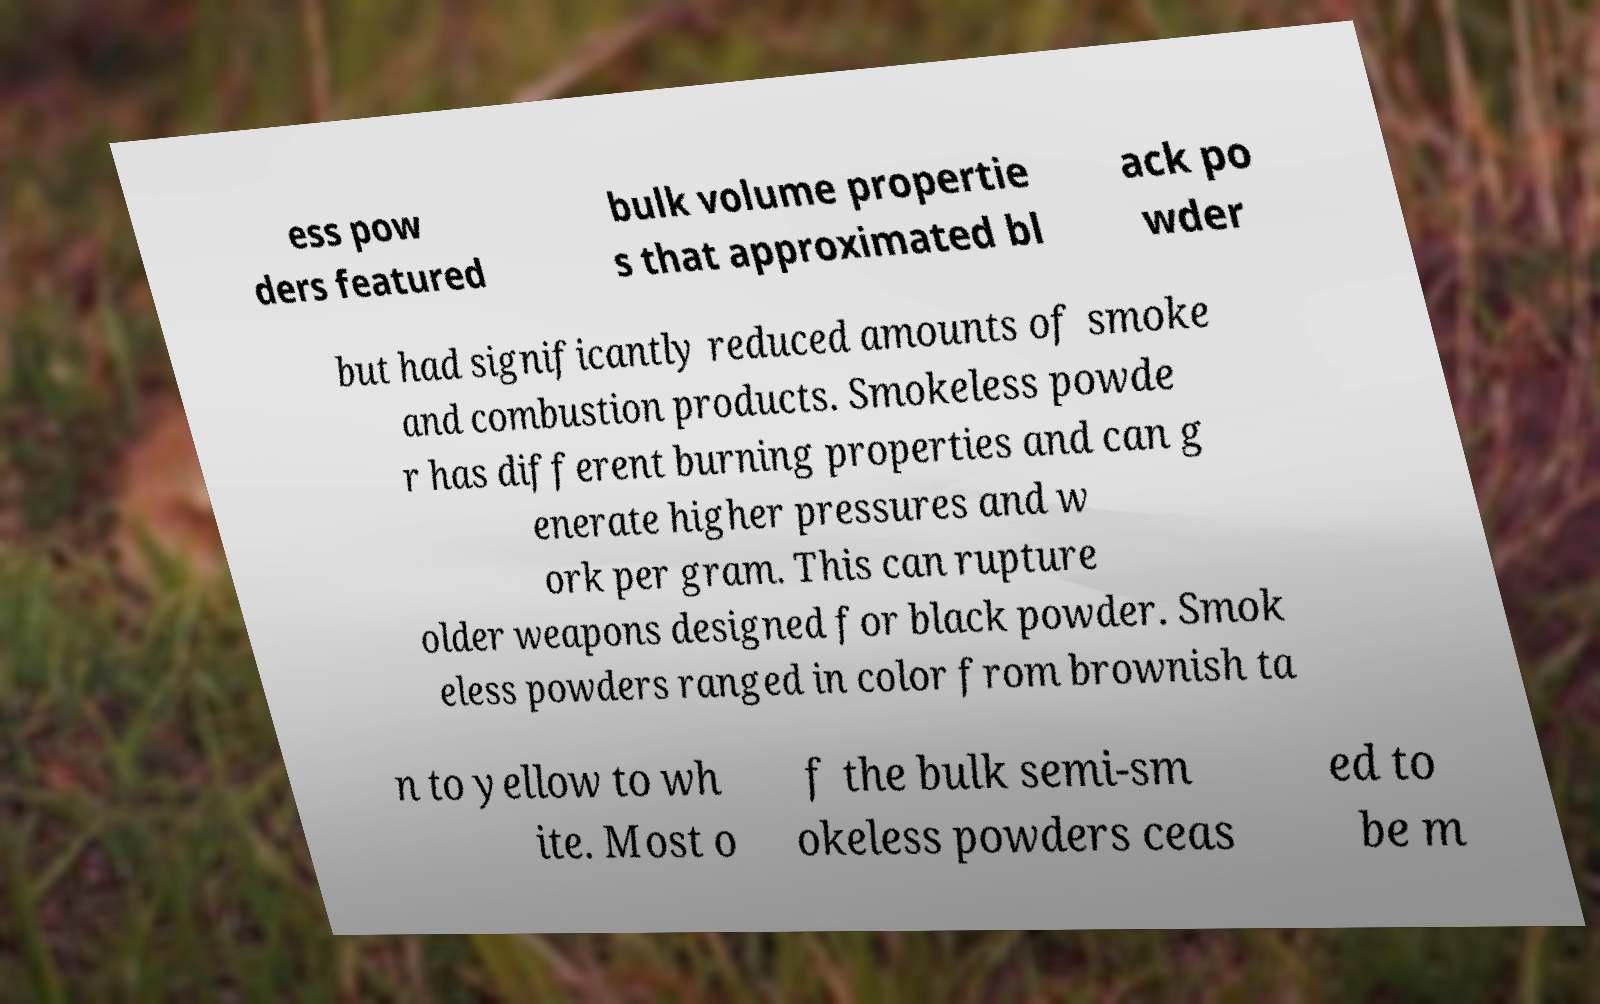There's text embedded in this image that I need extracted. Can you transcribe it verbatim? ess pow ders featured bulk volume propertie s that approximated bl ack po wder but had significantly reduced amounts of smoke and combustion products. Smokeless powde r has different burning properties and can g enerate higher pressures and w ork per gram. This can rupture older weapons designed for black powder. Smok eless powders ranged in color from brownish ta n to yellow to wh ite. Most o f the bulk semi-sm okeless powders ceas ed to be m 